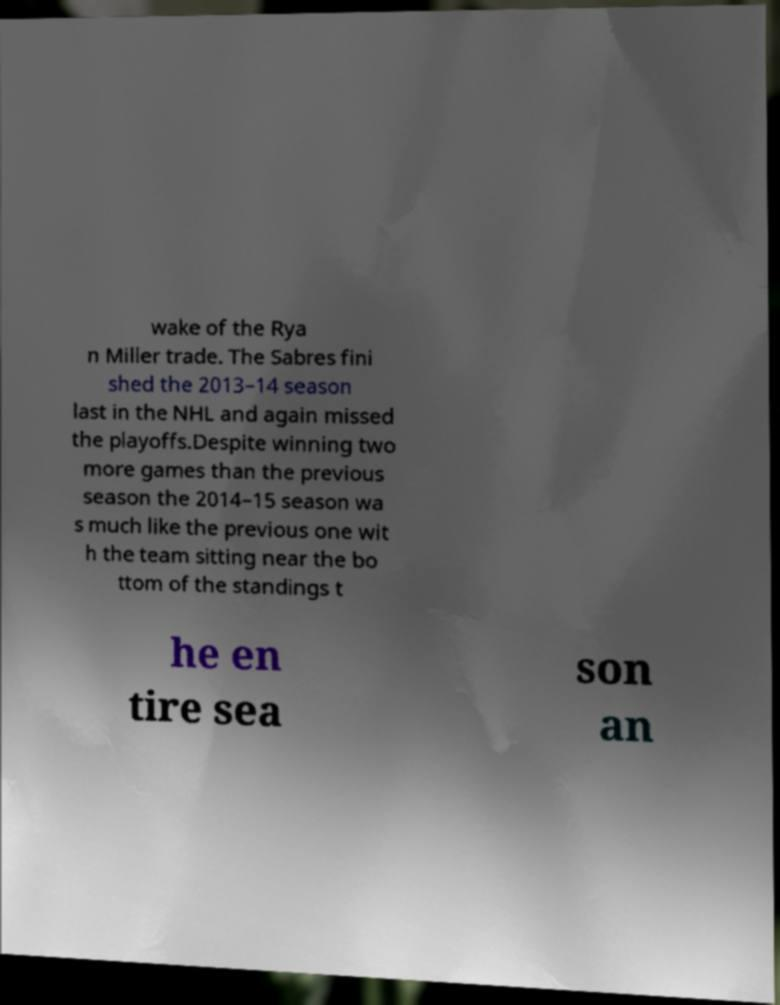What messages or text are displayed in this image? I need them in a readable, typed format. wake of the Rya n Miller trade. The Sabres fini shed the 2013–14 season last in the NHL and again missed the playoffs.Despite winning two more games than the previous season the 2014–15 season wa s much like the previous one wit h the team sitting near the bo ttom of the standings t he en tire sea son an 